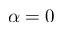Convert formula to latex. <formula><loc_0><loc_0><loc_500><loc_500>\alpha = 0</formula> 